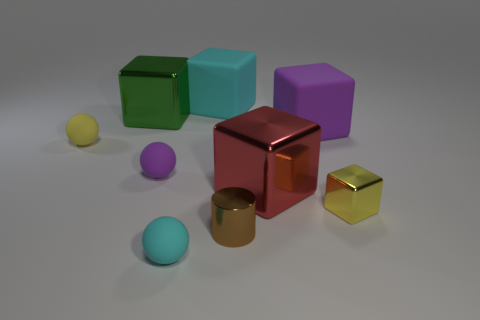Subtract all cyan blocks. How many blocks are left? 4 Subtract all gray cubes. Subtract all yellow spheres. How many cubes are left? 5 Add 1 green balls. How many objects exist? 10 Subtract all spheres. How many objects are left? 6 Subtract 1 cyan blocks. How many objects are left? 8 Subtract all small brown metallic cylinders. Subtract all large blocks. How many objects are left? 4 Add 3 big cyan objects. How many big cyan objects are left? 4 Add 4 rubber cubes. How many rubber cubes exist? 6 